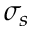<formula> <loc_0><loc_0><loc_500><loc_500>\sigma _ { s }</formula> 